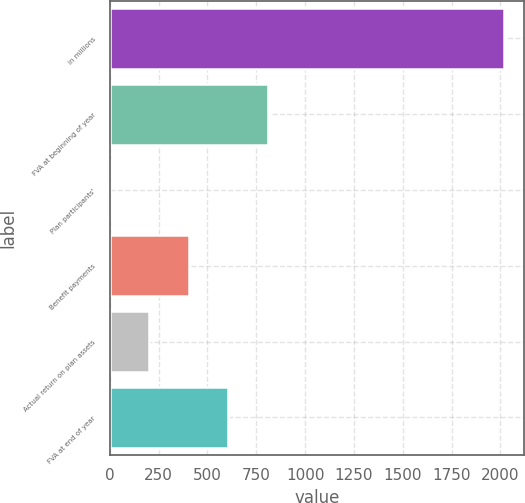Convert chart to OTSL. <chart><loc_0><loc_0><loc_500><loc_500><bar_chart><fcel>in millions<fcel>FVA at beginning of year<fcel>Plan participants'<fcel>Benefit payments<fcel>Actual return on plan assets<fcel>FVA at end of year<nl><fcel>2018<fcel>807.8<fcel>1<fcel>404.4<fcel>202.7<fcel>606.1<nl></chart> 